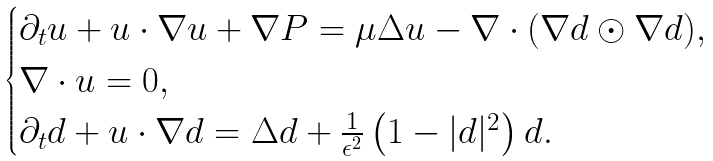<formula> <loc_0><loc_0><loc_500><loc_500>\begin{cases} \partial _ { t } u + u \cdot \nabla u + \nabla P = \mu \Delta u - \nabla \cdot ( \nabla d \odot \nabla d ) , \\ \nabla \cdot u = 0 , \\ \partial _ { t } d + u \cdot \nabla d = \Delta d + \frac { 1 } { \epsilon ^ { 2 } } \left ( 1 - | d | ^ { 2 } \right ) d . \end{cases}</formula> 